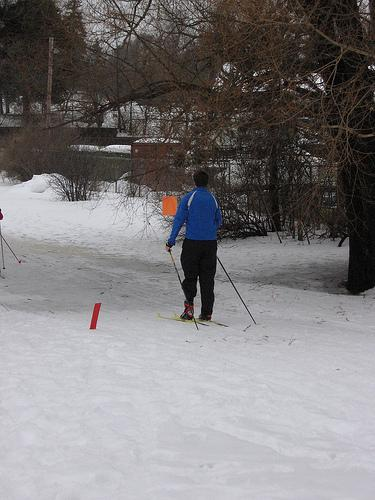What type of object is on the left side of the image, and what colors does it have? There is a red piece of plastic in the snow on the left side of the image, likely some sort of flag or marker. What type of skiing is the person in the image participating in? The person is likely participating in cross-country skiing. Point out the color and material of the pole situated behind the trees in the image. The tall pole behind the trees is wooden and appears to have a natural brown color. Identify the color of the jacket worn by the person in the image. The person in the image is wearing a bright blue jacket with white stripes. What is the state of snow in the image, and what color is it? The snow in the image is dirty white, covering the ground and providing a surface for skiing. Explain the appearance and location of the flag near the skier. There is an orange flag placed in front of the skier on the snow, captured by a bright orange color and rectangular shape. Can you identify any plant life in the image, and describe its appearance? There is a bush without leaves and a tree on the left side of the image, both having branches appearing bare. What kind of footgear does the person have on, and what colors are they? The person is wearing ski boots that are black and red in color. Describe the characteristics of the skis the person is using. The skis are bright yellow, possibly quite long, and positioned on the snow, ready for use. Give a brief description of the setting in which this image takes place. The image takes place in a snow-covered outdoor setting with a ski trail by the water and a person cross country skiing through the snowy terrain. Is the wall made of concrete? The wall is made of bricks, not concrete. How many purple flags can you see in the scene? There are only red and orange flags in the scene, no purple flags. Can you spot the tree full of leaves? The tree branches have no leaves, not full of leaves. Find the skier wearing pink pants. The skier is wearing black pants, not pink pants. Can you find an orange sign buried in the snow? The orange sign is on the snow, not buried in the snow. Does the man have a green jacket? The man is wearing a blue jacket, not a green one. Is there a person standing in front of the cross-country skier? There is no person in front of the cross-country skier. Look for a pair of white skis. The skis are yellow, not white. Please notice a tall metal pole in the image. The pole is wooden, not metal. Does the blue jacket have red stripes? The blue jacket has white stripes, not red stripes.  